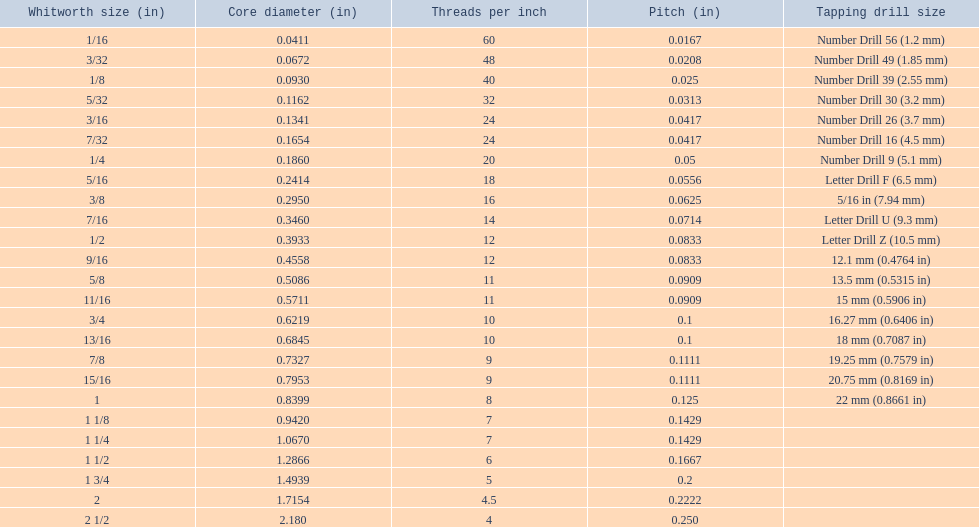What are the standard whitworth sizes in inches? 1/16, 3/32, 1/8, 5/32, 3/16, 7/32, 1/4, 5/16, 3/8, 7/16, 1/2, 9/16, 5/8, 11/16, 3/4, 13/16, 7/8, 15/16, 1, 1 1/8, 1 1/4, 1 1/2, 1 3/4, 2, 2 1/2. How many threads per inch does the 3/16 size have? 24. Which size (in inches) has the same number of threads? 7/32. 